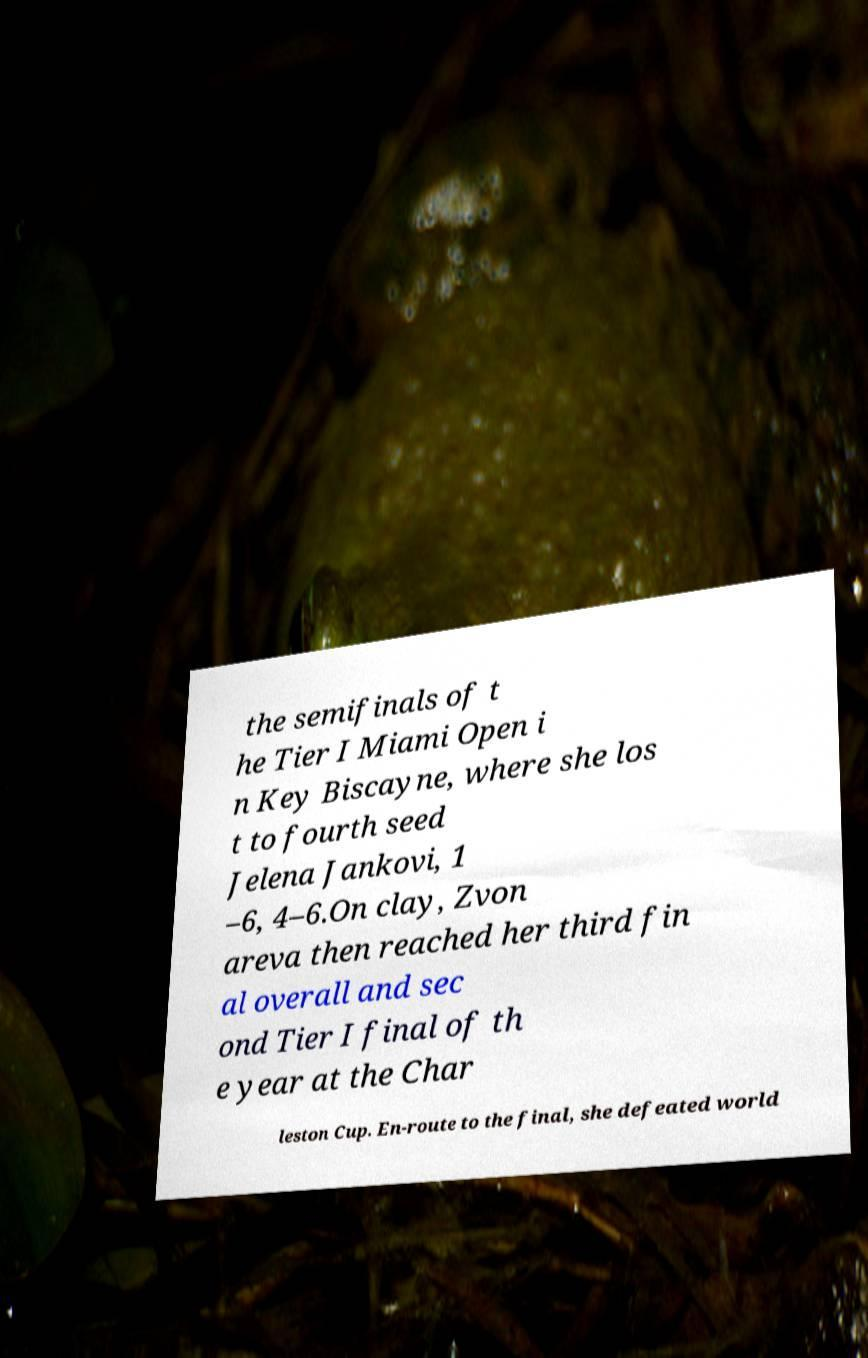Please identify and transcribe the text found in this image. the semifinals of t he Tier I Miami Open i n Key Biscayne, where she los t to fourth seed Jelena Jankovi, 1 –6, 4–6.On clay, Zvon areva then reached her third fin al overall and sec ond Tier I final of th e year at the Char leston Cup. En-route to the final, she defeated world 